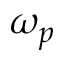Convert formula to latex. <formula><loc_0><loc_0><loc_500><loc_500>\omega _ { p }</formula> 